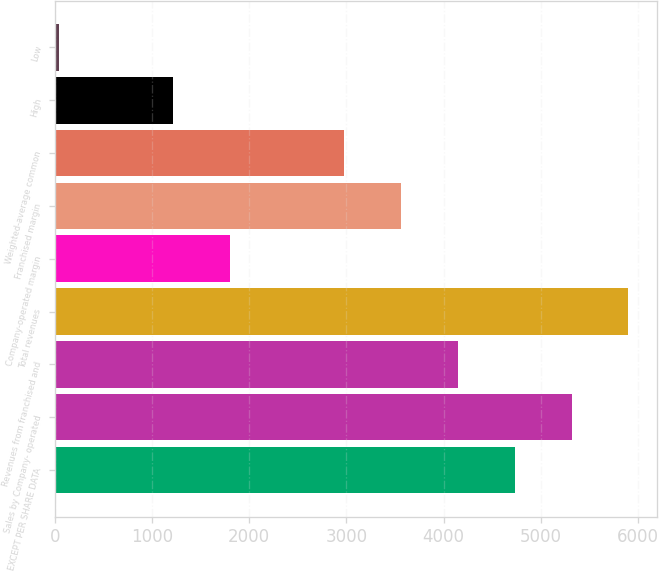Convert chart to OTSL. <chart><loc_0><loc_0><loc_500><loc_500><bar_chart><fcel>EXCEPT PER SHARE DATA<fcel>Sales by Company- operated<fcel>Revenues from franchised and<fcel>Total revenues<fcel>Company-operated margin<fcel>Franchised margin<fcel>Weighted-average common<fcel>High<fcel>Low<nl><fcel>4730.08<fcel>5315.51<fcel>4144.65<fcel>5900.94<fcel>1802.93<fcel>3559.22<fcel>2973.79<fcel>1217.5<fcel>46.64<nl></chart> 